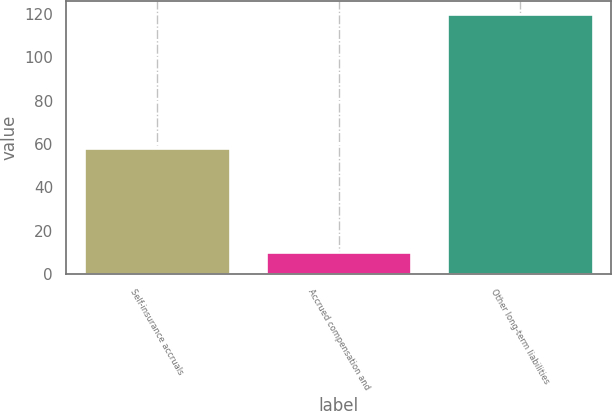Convert chart. <chart><loc_0><loc_0><loc_500><loc_500><bar_chart><fcel>Self-insurance accruals<fcel>Accrued compensation and<fcel>Other long-term liabilities<nl><fcel>58<fcel>10<fcel>120<nl></chart> 